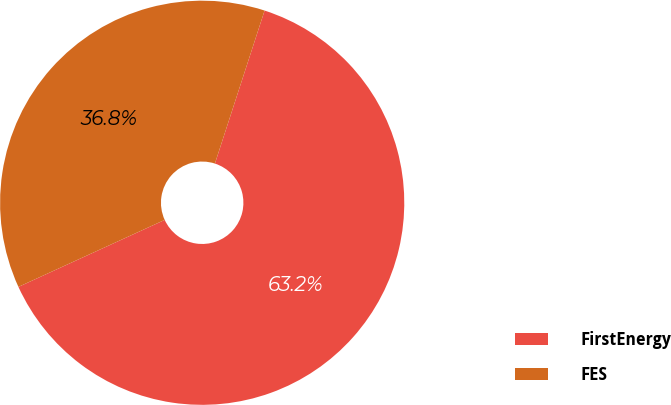<chart> <loc_0><loc_0><loc_500><loc_500><pie_chart><fcel>FirstEnergy<fcel>FES<nl><fcel>63.17%<fcel>36.83%<nl></chart> 